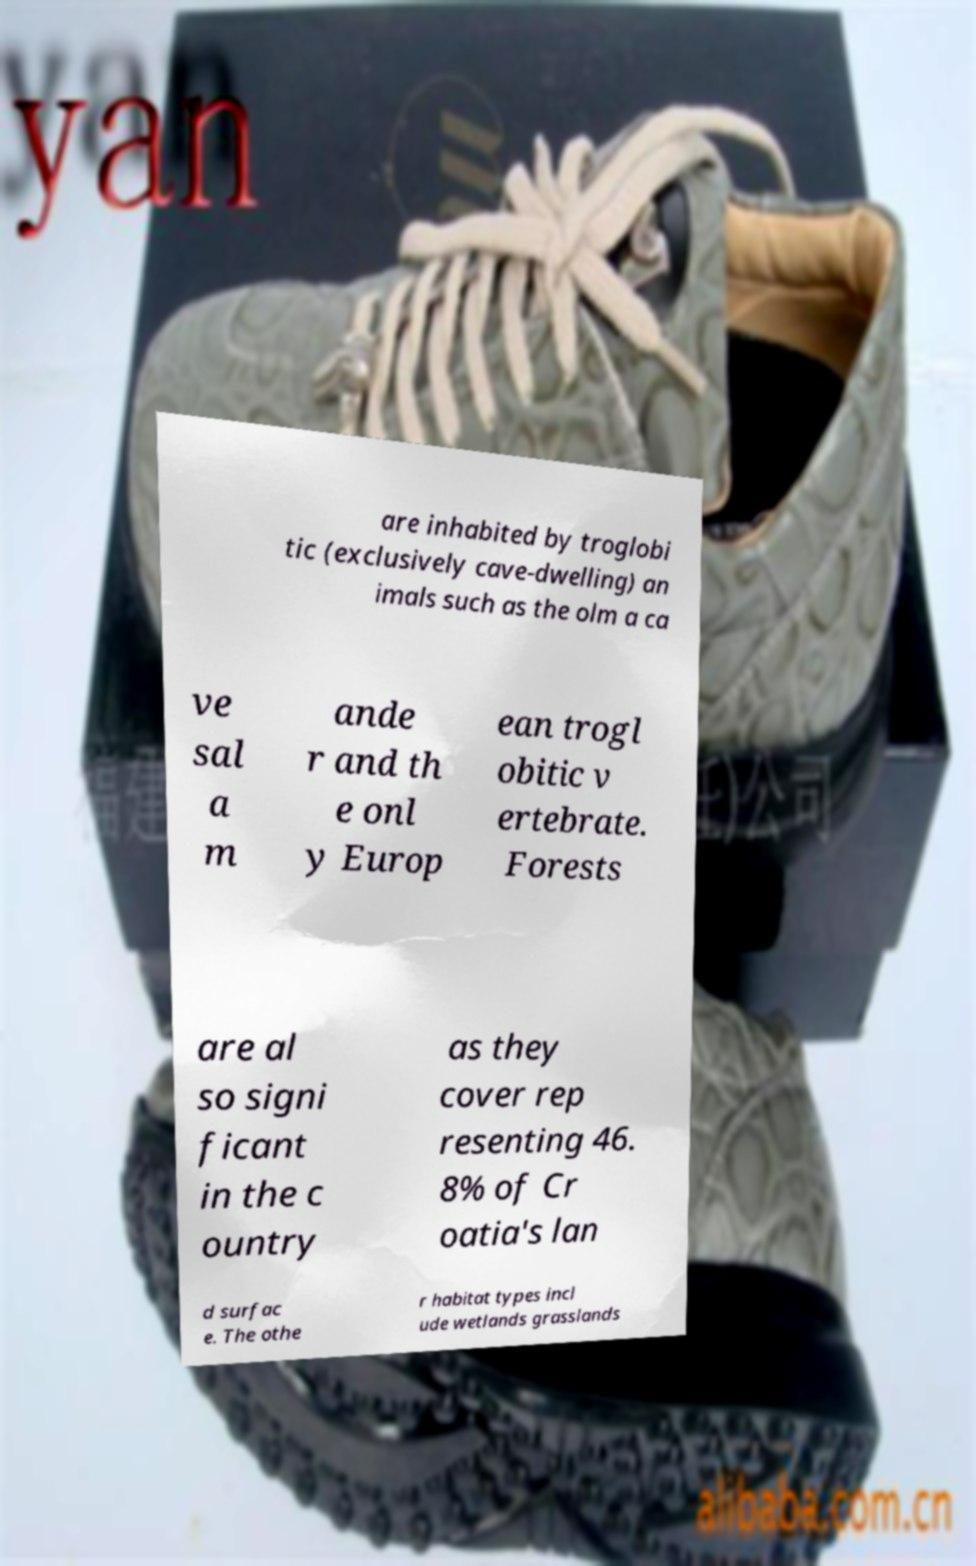There's text embedded in this image that I need extracted. Can you transcribe it verbatim? are inhabited by troglobi tic (exclusively cave-dwelling) an imals such as the olm a ca ve sal a m ande r and th e onl y Europ ean trogl obitic v ertebrate. Forests are al so signi ficant in the c ountry as they cover rep resenting 46. 8% of Cr oatia's lan d surfac e. The othe r habitat types incl ude wetlands grasslands 